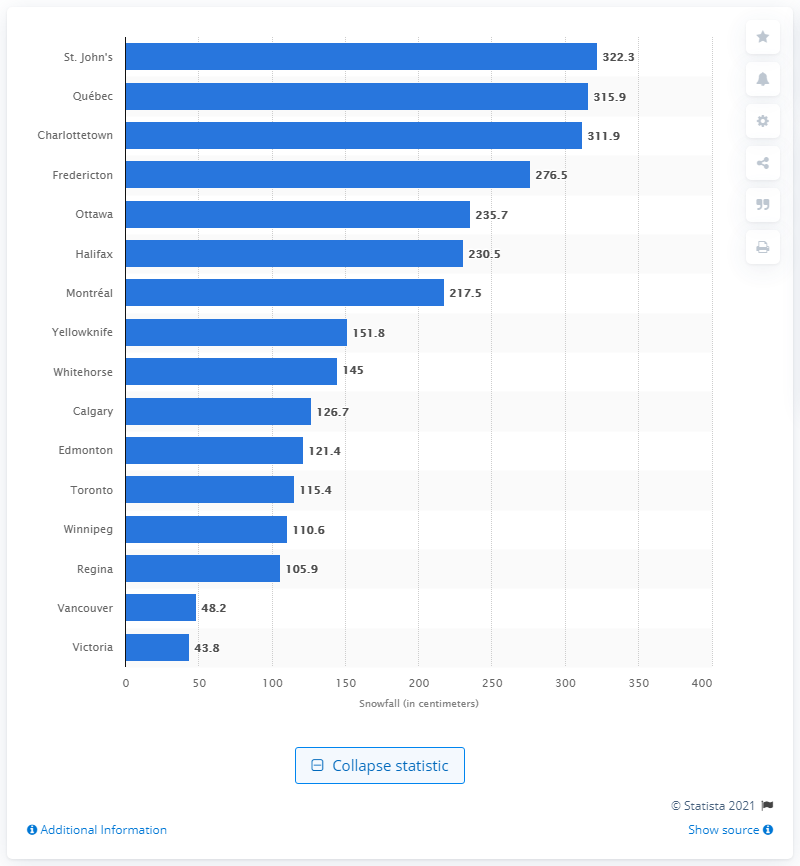Point out several critical features in this image. According to data from 1971 to 2000, the city of Victoria in Canada received an average of 43.8 centimeters of snow annually. This is the city that received the highest amount of snowfall in Canada during that time period. 